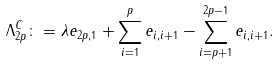Convert formula to latex. <formula><loc_0><loc_0><loc_500><loc_500>\Lambda ^ { C } _ { 2 p } \colon = \lambda e _ { 2 p , 1 } + \sum _ { i = 1 } ^ { p } e _ { i , i + 1 } - \sum _ { i = p + 1 } ^ { 2 p - 1 } e _ { i , i + 1 } .</formula> 